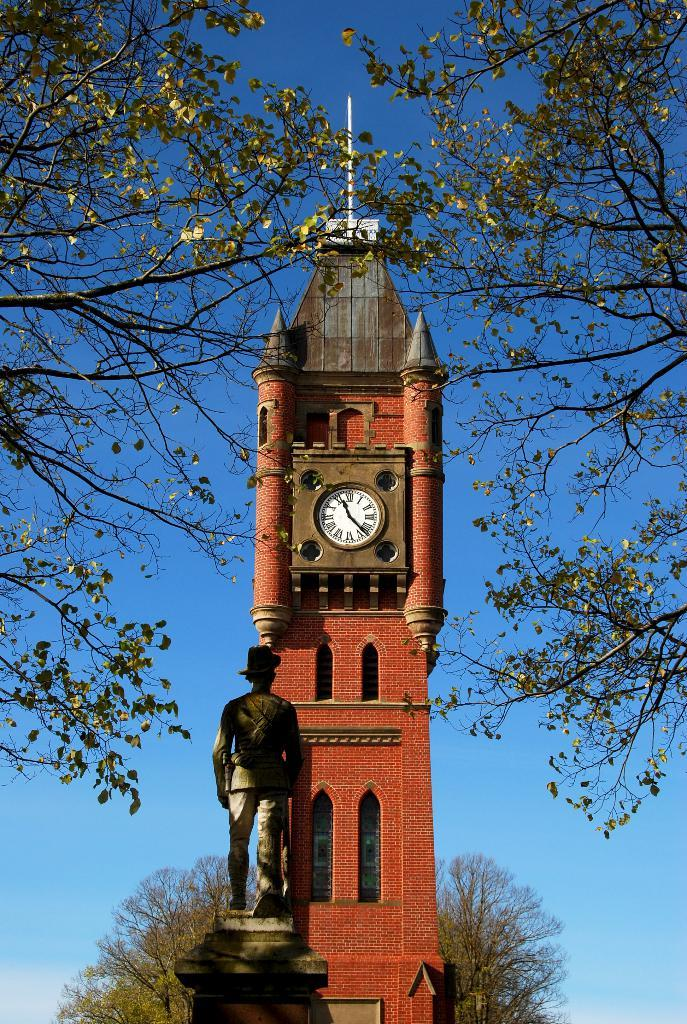<image>
Create a compact narrative representing the image presented. Tall tower with a clock which has hands on the 11 and 5. 